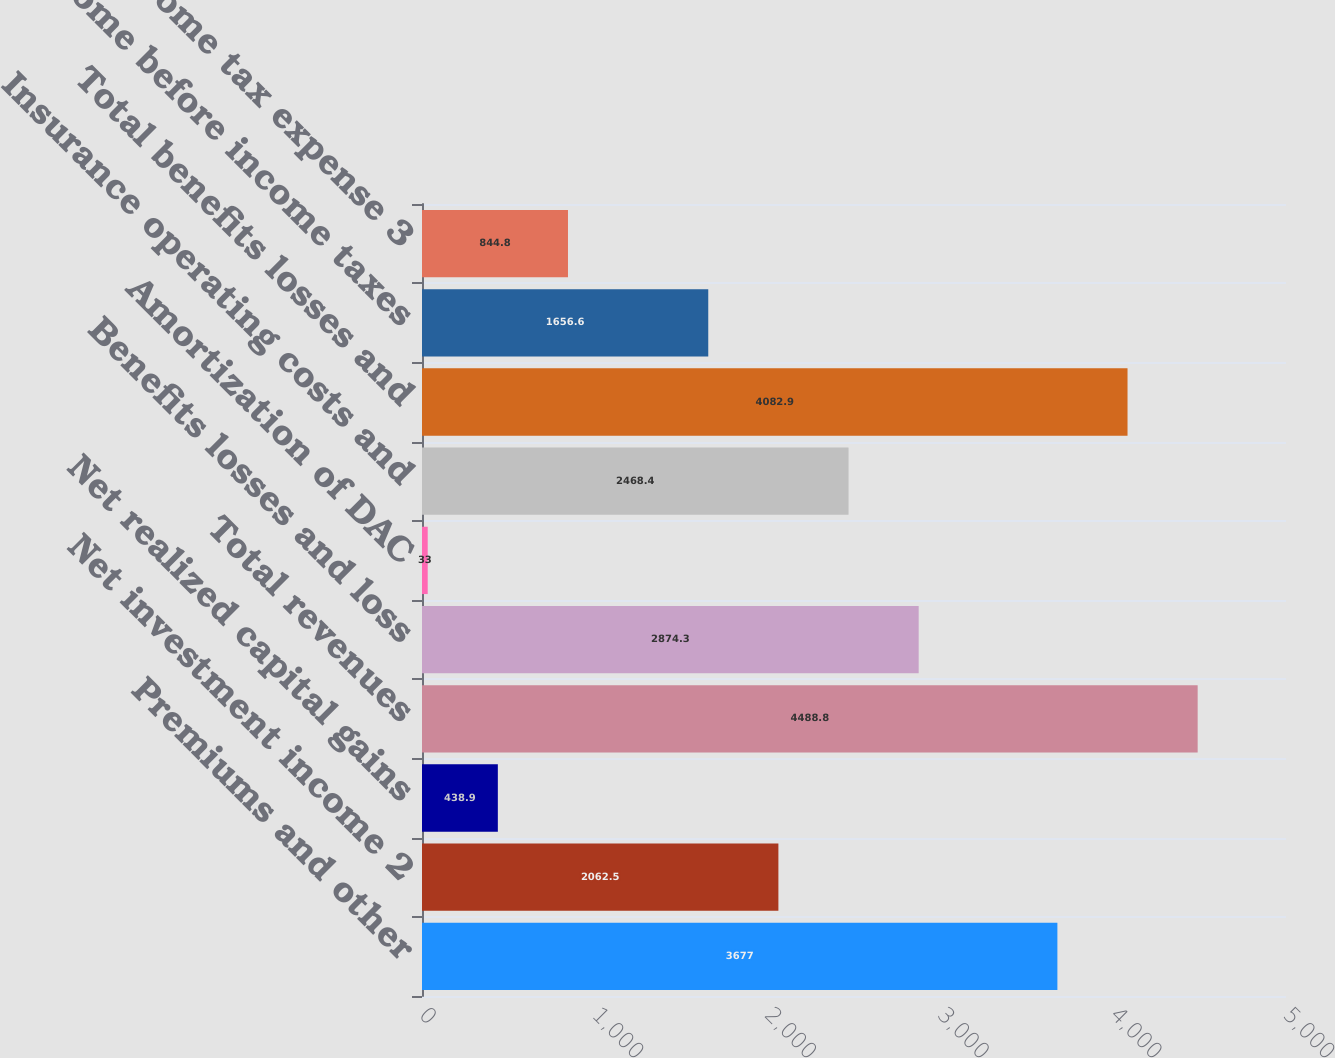Convert chart to OTSL. <chart><loc_0><loc_0><loc_500><loc_500><bar_chart><fcel>Premiums and other<fcel>Net investment income 2<fcel>Net realized capital gains<fcel>Total revenues<fcel>Benefits losses and loss<fcel>Amortization of DAC<fcel>Insurance operating costs and<fcel>Total benefits losses and<fcel>Income before income taxes<fcel>Income tax expense 3<nl><fcel>3677<fcel>2062.5<fcel>438.9<fcel>4488.8<fcel>2874.3<fcel>33<fcel>2468.4<fcel>4082.9<fcel>1656.6<fcel>844.8<nl></chart> 